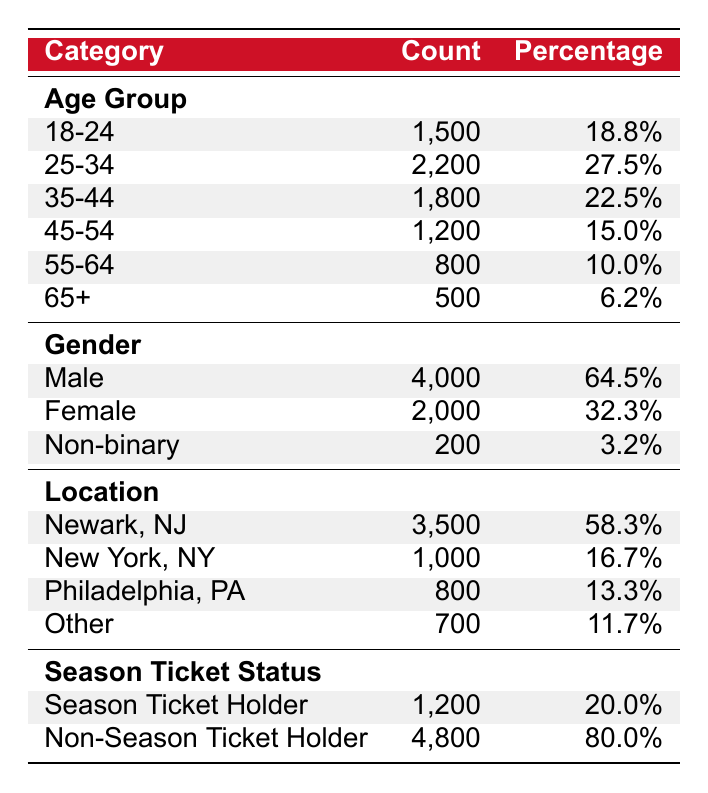what is the total number of fans aged 35 and above? To find the total number of fans aged 35 and above, we need to add the counts for the age groups 35-44, 45-54, 55-64, and 65+. Thus, we calculate: 1800 (35-44) + 1200 (45-54) + 800 (55-64) + 500 (65+) = 3300.
Answer: 3300 what percentage of fans are female? According to the table, there are 2000 female fans out of a total of 6000 fans (4000 males + 2000 females + 200 non-binary). The percentage is calculated as (2000/6000) * 100 = 33.3%.
Answer: 33.3% is the majority of fans from Newark, NJ? Yes, Newark, NJ has the highest count of fans, with 3500 fans attending home games, which is greater than the combined total of fans from New York, Philadelphia, and other locations (1000 + 800 + 700 = 2500).
Answer: Yes what is the difference in the number of male and female fans? The number of male fans is 4000 and the number of female fans is 2000. The difference is calculated by subtracting the number of female fans from the number of male fans: 4000 - 2000 = 2000.
Answer: 2000 what is the ratio of season ticket holders to non-season ticket holders? The number of season ticket holders is 1200, and the number of non-season ticket holders is 4800. The ratio is represented as 1200:4800. To simplify, we divide both numbers by 1200, which gives us a simplified ratio of 1:4.
Answer: 1:4 how many fans are from locations other than Newark, New York, and Philadelphia? We need to count the fans from the "Other" category, which has 700 fans. Since Newark and New York are accounted for, and Philadelphia is also excluded, only the "Other" category remains relevant.
Answer: 700 what age group represents the largest percentage of fans? The age group 25-34 has the highest count of fans at 2200, which is 27.5% of the total. To confirm, we compare it with other age groups and see that they all have lower percentages.
Answer: 25-34 calculate the average number of fans across all age groups. To find the average, we first sum the counts for all age groups: 1500 + 2200 + 1800 + 1200 + 800 + 500 = 10000. We then divide by the number of age groups, which is 6: 10000 / 6 = 1666.67.
Answer: 1666.67 how many total fans are attending games? To find the total number of fans, we sum the counts across all categories. The total is computed as follows: 1500 (18-24) + 2200 (25-34) + 1800 (35-44) + 1200 (45-54) + 800 (55-64) + 500 (65+) + 4000 (Male) + 2000 (Female) + 200 (Non-binary) + 3500 (Newark) + 1000 (New York) + 800 (Philadelphia) + 700 (Other) + 1200 (Season Ticket Holders) + 4800 (Non-Season Ticket Holders) = 6000. However, since some values are included in multiple categories, we just look at either the gender or the season ticket statistics, arriving at the total of 6000 from each context.
Answer: 6000 